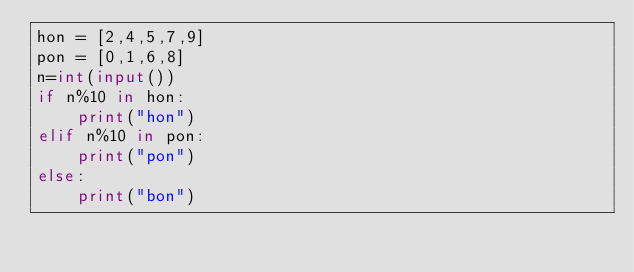Convert code to text. <code><loc_0><loc_0><loc_500><loc_500><_Python_>hon = [2,4,5,7,9]
pon = [0,1,6,8]
n=int(input())
if n%10 in hon:
    print("hon")
elif n%10 in pon:
    print("pon")
else:
    print("bon")</code> 